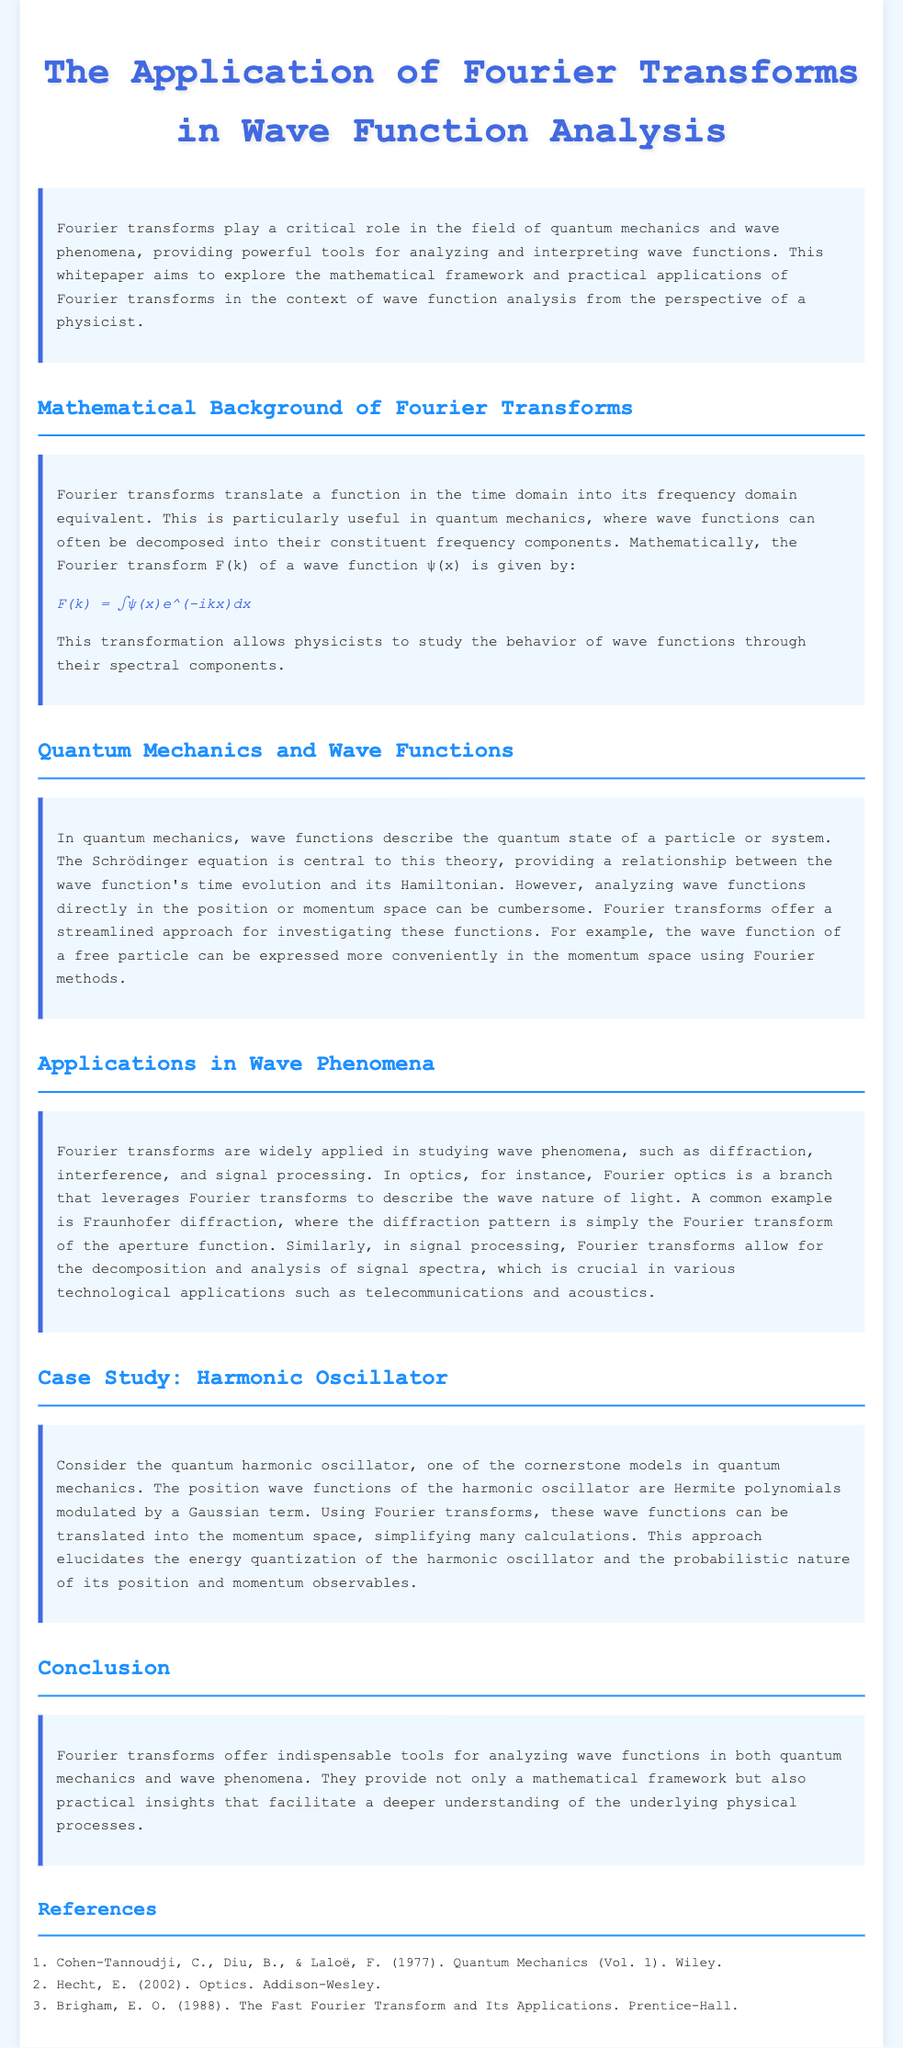What is the title of the whitepaper? The title of the whitepaper is stated at the beginning of the document.
Answer: The Application of Fourier Transforms in Wave Function Analysis What is the mathematical equation for the Fourier transform of a wave function? The equation for the Fourier transform is specified in the section discussing the mathematical background.
Answer: F(k) = ∫ψ(x)e^(-ikx)dx Which quantum model is used as a case study in the whitepaper? The case study section specifically mentions a prominent quantum model to illustrate the application of Fourier transforms.
Answer: Harmonic Oscillator What is one application of Fourier transforms in optics mentioned in the document? The applications section describes various instances where Fourier transforms are utilized in wave phenomena, including a specific optical application.
Answer: Fraunhofer diffraction What do Fourier transforms help analyze in quantum mechanics? The conclusion emphasizes the general importance of Fourier transforms in wave function analysis within the context of quantum mechanics.
Answer: Wave functions How do Fourier transforms simplify the analysis of wave functions? The document explains that Fourier transforms provide a way to decompose functions into spectral components, streamlining analyses.
Answer: By translating functions into frequency components What is a key reason for using Fourier transforms in signal processing? The application section underlines the significance of Fourier transforms in the context of technology-related applications.
Answer: Decomposition and analysis of signal spectra 